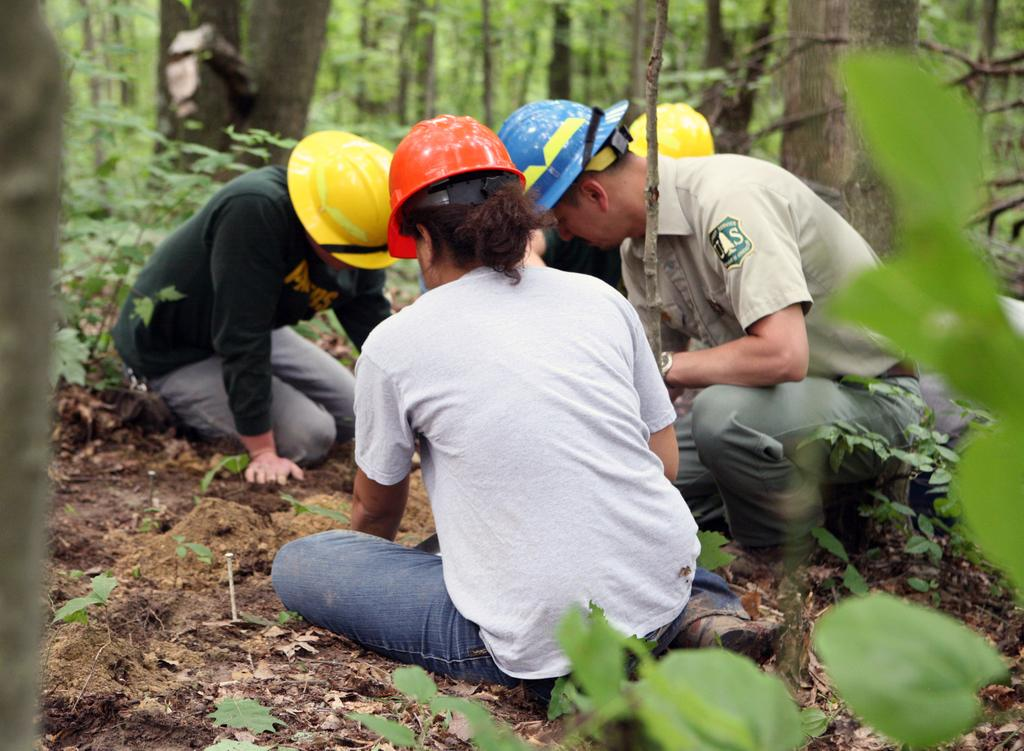What are the people in the image wearing on their heads? The people in the image are wearing helmets. What position are the people in the image? The people are sitting on the ground. What type of vegetation can be seen in the image? There are plants and trees in the image. What type of pie is being served at the party in the image? There is no pie or party present in the image; it features people wearing helmets and sitting on the ground with plants and trees in the background. How many dimes are visible on the ground in the image? There are no dimes visible in the image. 